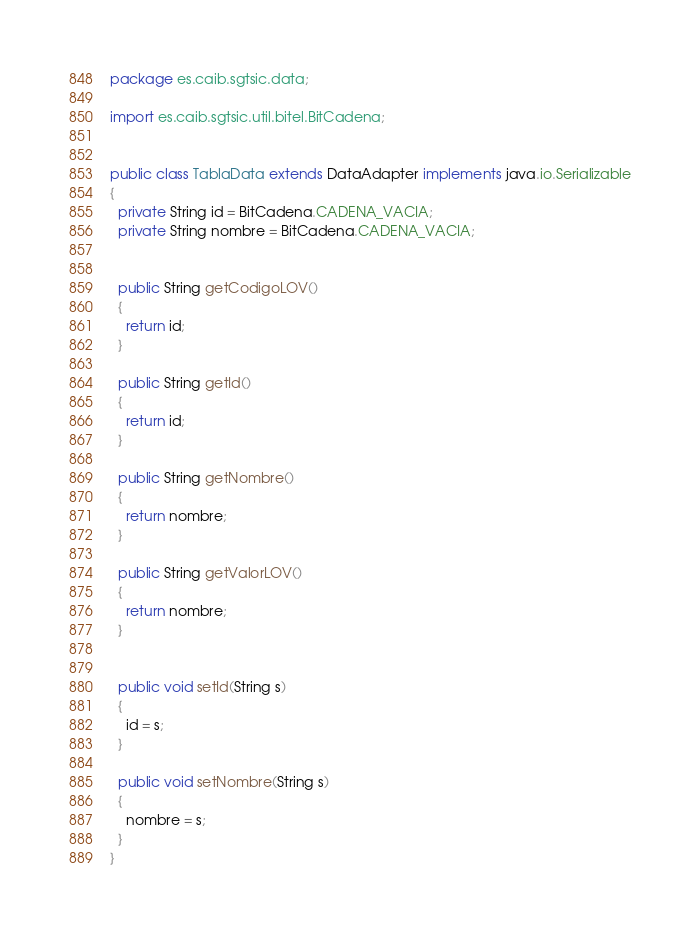Convert code to text. <code><loc_0><loc_0><loc_500><loc_500><_Java_>package es.caib.sgtsic.data;

import es.caib.sgtsic.util.bitel.BitCadena;


public class TablaData extends DataAdapter implements java.io.Serializable
{
  private String id = BitCadena.CADENA_VACIA;
  private String nombre = BitCadena.CADENA_VACIA;


  public String getCodigoLOV()
  {
    return id;
  }

  public String getId()
  {
    return id;
  }

  public String getNombre()
  {
    return nombre;
  }

  public String getValorLOV()
  {
    return nombre;
  }


  public void setId(String s)
  {
    id = s;
  }

  public void setNombre(String s)
  {
    nombre = s;
  }
}
</code> 